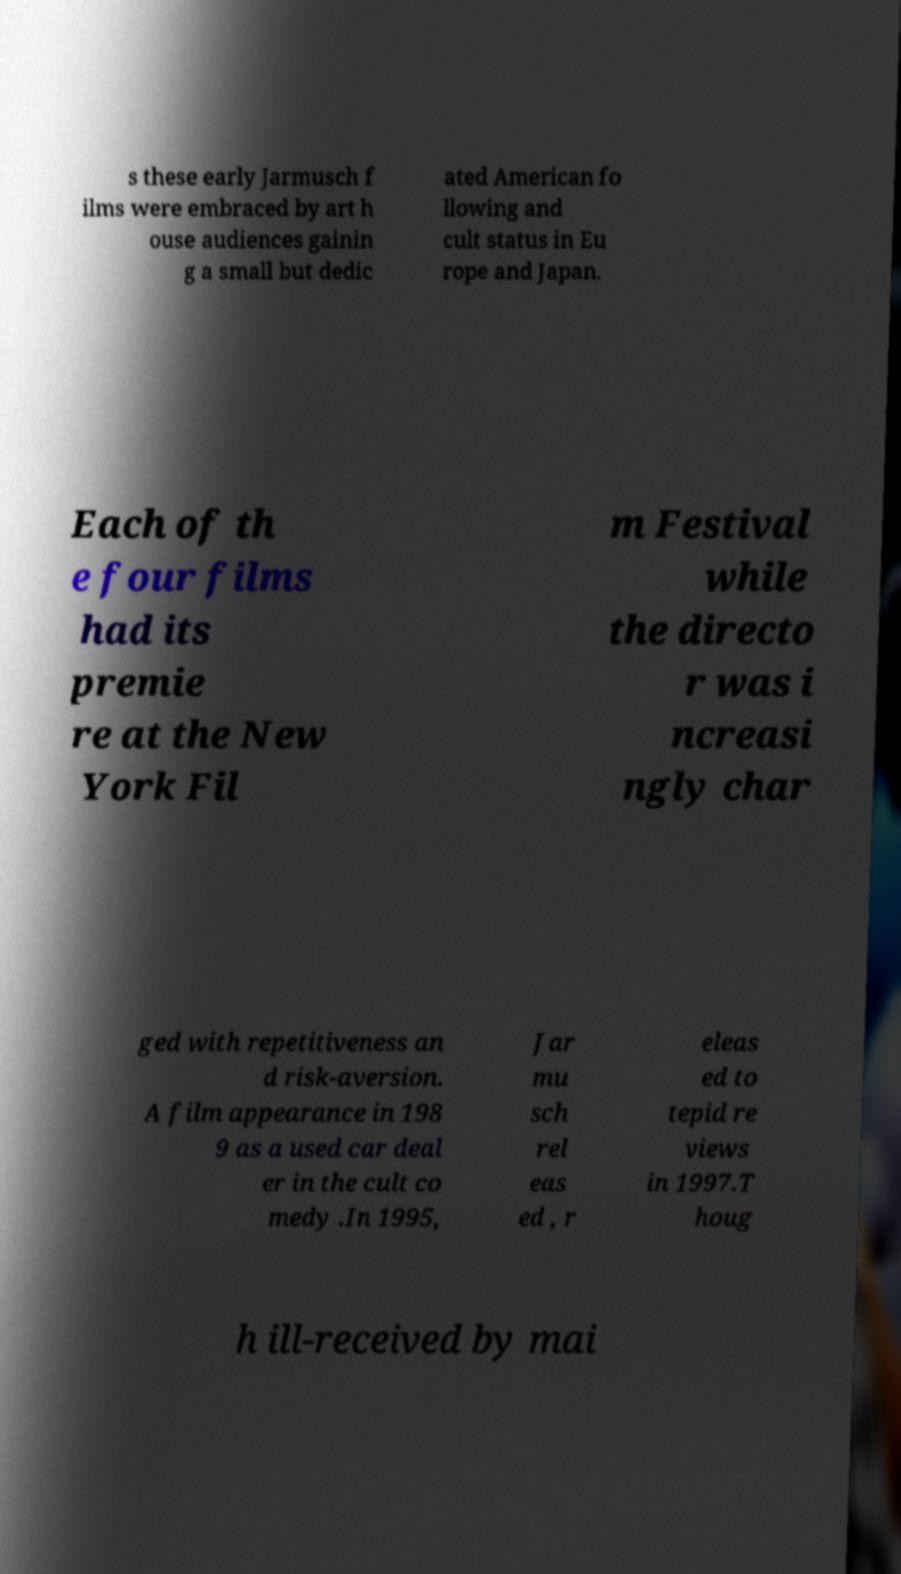What messages or text are displayed in this image? I need them in a readable, typed format. s these early Jarmusch f ilms were embraced by art h ouse audiences gainin g a small but dedic ated American fo llowing and cult status in Eu rope and Japan. Each of th e four films had its premie re at the New York Fil m Festival while the directo r was i ncreasi ngly char ged with repetitiveness an d risk-aversion. A film appearance in 198 9 as a used car deal er in the cult co medy .In 1995, Jar mu sch rel eas ed , r eleas ed to tepid re views in 1997.T houg h ill-received by mai 